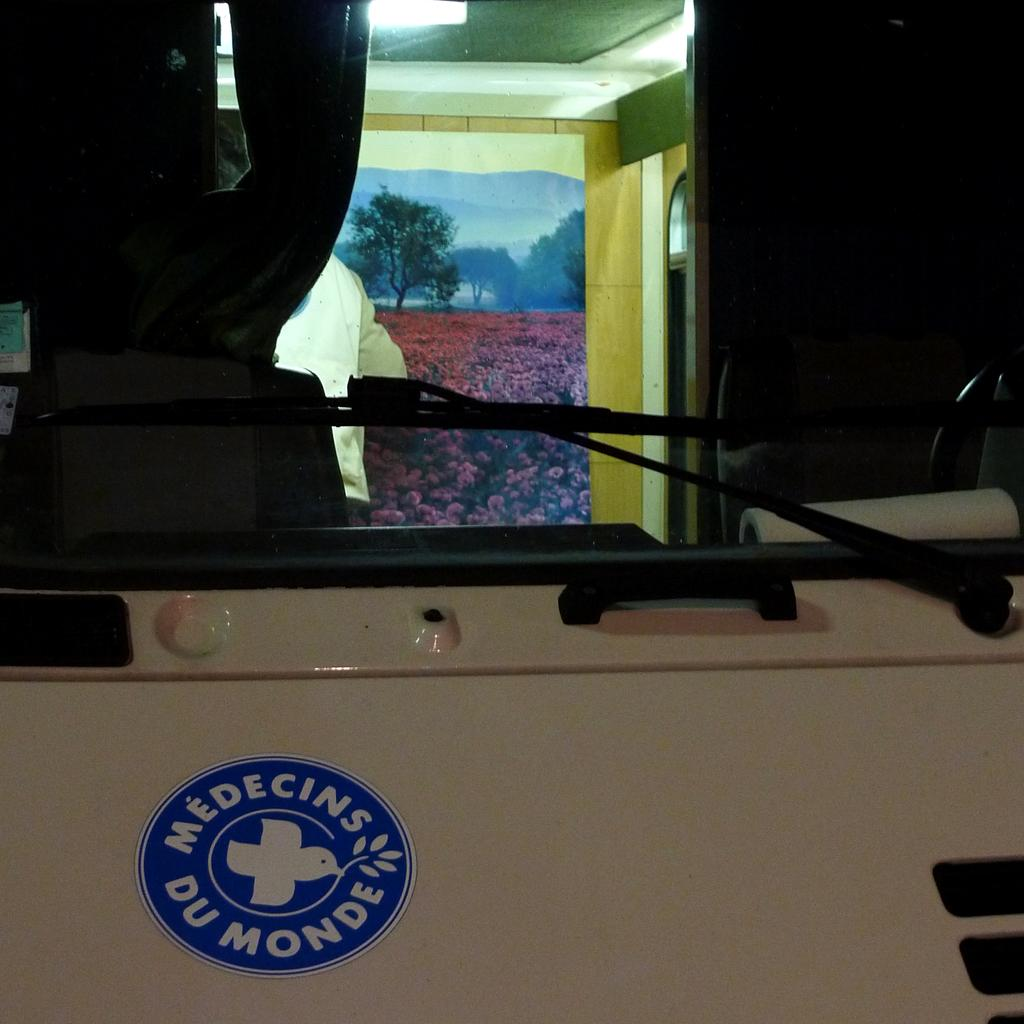What is the main subject of the image? The main subject of the image is a vehicle. What feature can be seen on the vehicle's glass? The vehicle has wipers on the glass. Is there anyone inside the vehicle? Yes, there is a person inside the vehicle. What is attached to the wooden wall inside the vehicle? There is a poster attached to a wooden wall in the vehicle. What type of glove can be seen hanging from the rearview mirror in the image? There is no glove hanging from the rearview mirror in the image. What punishment is the person inside the vehicle receiving for their actions? There is no indication of any punishment being given in the image; it simply shows a person inside a vehicle with a poster on the wall. 